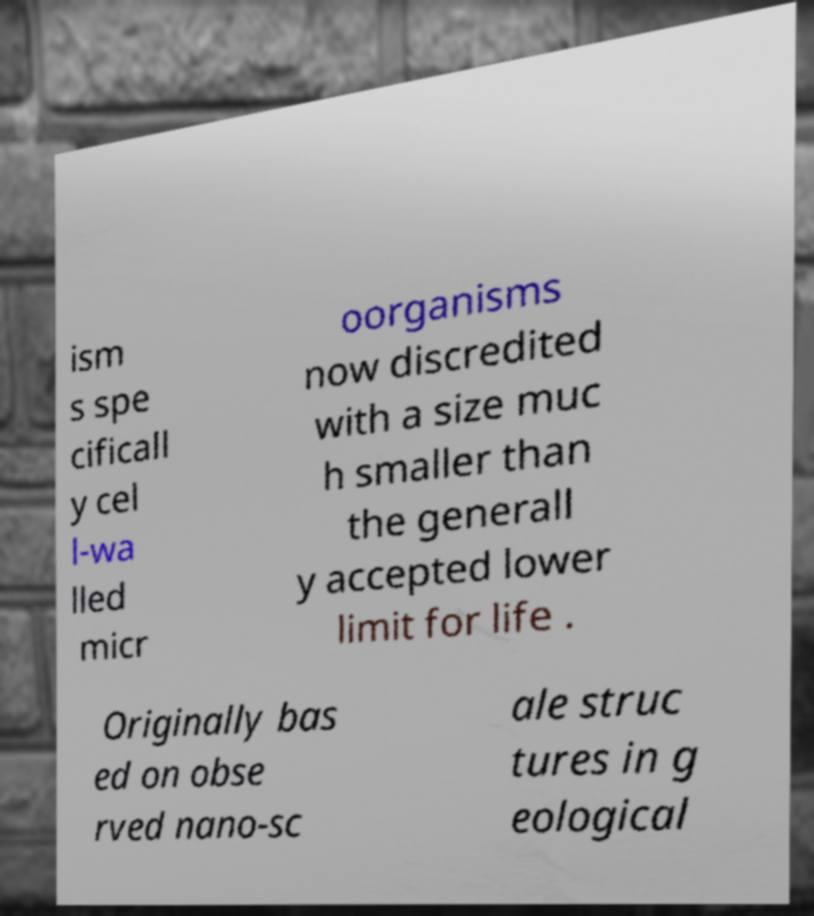What messages or text are displayed in this image? I need them in a readable, typed format. ism s spe cificall y cel l-wa lled micr oorganisms now discredited with a size muc h smaller than the generall y accepted lower limit for life . Originally bas ed on obse rved nano-sc ale struc tures in g eological 